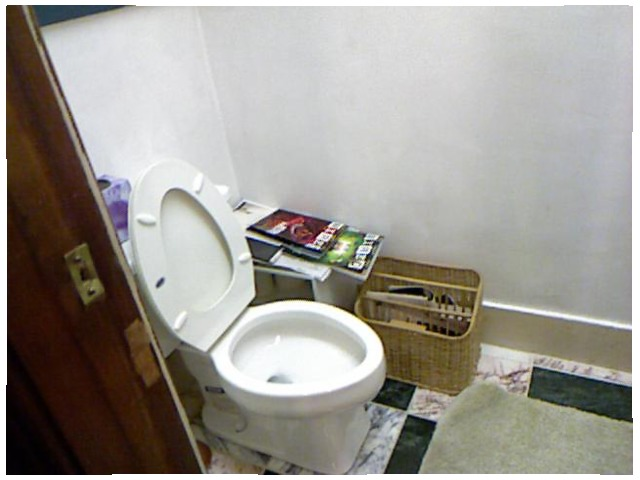<image>
Is there a toilet closet to the right of the book? No. The toilet closet is not to the right of the book. The horizontal positioning shows a different relationship. Is the basket to the left of the toilet? Yes. From this viewpoint, the basket is positioned to the left side relative to the toilet. Is there a water in the toilet? Yes. The water is contained within or inside the toilet, showing a containment relationship. Is there a basket next to the toilet? Yes. The basket is positioned adjacent to the toilet, located nearby in the same general area. 